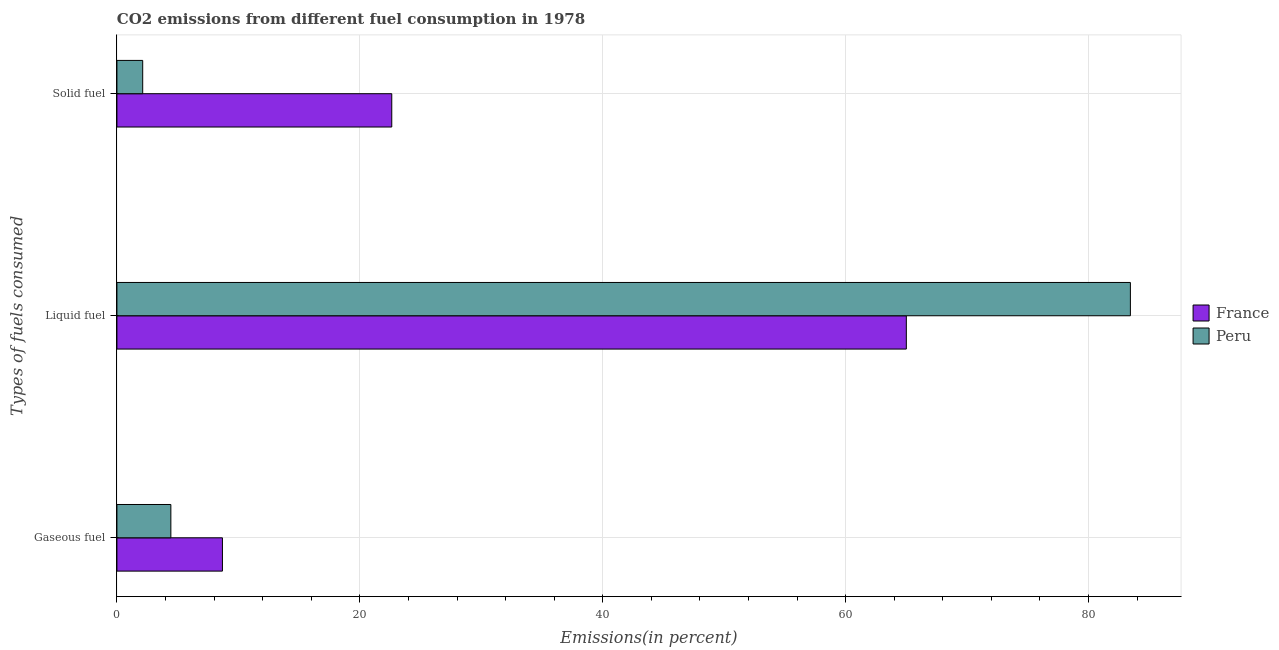How many groups of bars are there?
Provide a short and direct response. 3. Are the number of bars per tick equal to the number of legend labels?
Make the answer very short. Yes. How many bars are there on the 1st tick from the top?
Give a very brief answer. 2. What is the label of the 3rd group of bars from the top?
Make the answer very short. Gaseous fuel. What is the percentage of liquid fuel emission in France?
Offer a terse response. 65. Across all countries, what is the maximum percentage of liquid fuel emission?
Offer a terse response. 83.44. Across all countries, what is the minimum percentage of gaseous fuel emission?
Keep it short and to the point. 4.44. In which country was the percentage of gaseous fuel emission maximum?
Provide a succinct answer. France. In which country was the percentage of gaseous fuel emission minimum?
Provide a short and direct response. Peru. What is the total percentage of liquid fuel emission in the graph?
Your response must be concise. 148.44. What is the difference between the percentage of liquid fuel emission in Peru and that in France?
Your answer should be very brief. 18.45. What is the difference between the percentage of gaseous fuel emission in France and the percentage of liquid fuel emission in Peru?
Keep it short and to the point. -74.76. What is the average percentage of solid fuel emission per country?
Your answer should be compact. 12.38. What is the difference between the percentage of gaseous fuel emission and percentage of liquid fuel emission in France?
Provide a short and direct response. -56.31. What is the ratio of the percentage of gaseous fuel emission in Peru to that in France?
Make the answer very short. 0.51. Is the difference between the percentage of liquid fuel emission in France and Peru greater than the difference between the percentage of gaseous fuel emission in France and Peru?
Offer a terse response. No. What is the difference between the highest and the second highest percentage of solid fuel emission?
Your response must be concise. 20.51. What is the difference between the highest and the lowest percentage of solid fuel emission?
Offer a terse response. 20.51. In how many countries, is the percentage of gaseous fuel emission greater than the average percentage of gaseous fuel emission taken over all countries?
Keep it short and to the point. 1. Is the sum of the percentage of gaseous fuel emission in France and Peru greater than the maximum percentage of liquid fuel emission across all countries?
Offer a very short reply. No. What does the 1st bar from the top in Gaseous fuel represents?
Offer a terse response. Peru. What does the 2nd bar from the bottom in Solid fuel represents?
Give a very brief answer. Peru. Is it the case that in every country, the sum of the percentage of gaseous fuel emission and percentage of liquid fuel emission is greater than the percentage of solid fuel emission?
Offer a terse response. Yes. How many bars are there?
Provide a succinct answer. 6. Are all the bars in the graph horizontal?
Give a very brief answer. Yes. Are the values on the major ticks of X-axis written in scientific E-notation?
Your response must be concise. No. Where does the legend appear in the graph?
Your response must be concise. Center right. What is the title of the graph?
Keep it short and to the point. CO2 emissions from different fuel consumption in 1978. Does "Lao PDR" appear as one of the legend labels in the graph?
Your response must be concise. No. What is the label or title of the X-axis?
Offer a terse response. Emissions(in percent). What is the label or title of the Y-axis?
Provide a short and direct response. Types of fuels consumed. What is the Emissions(in percent) of France in Gaseous fuel?
Your response must be concise. 8.69. What is the Emissions(in percent) of Peru in Gaseous fuel?
Your answer should be compact. 4.44. What is the Emissions(in percent) in France in Liquid fuel?
Keep it short and to the point. 65. What is the Emissions(in percent) of Peru in Liquid fuel?
Offer a very short reply. 83.44. What is the Emissions(in percent) in France in Solid fuel?
Keep it short and to the point. 22.63. What is the Emissions(in percent) in Peru in Solid fuel?
Make the answer very short. 2.12. Across all Types of fuels consumed, what is the maximum Emissions(in percent) in France?
Provide a short and direct response. 65. Across all Types of fuels consumed, what is the maximum Emissions(in percent) of Peru?
Make the answer very short. 83.44. Across all Types of fuels consumed, what is the minimum Emissions(in percent) of France?
Offer a very short reply. 8.69. Across all Types of fuels consumed, what is the minimum Emissions(in percent) of Peru?
Give a very brief answer. 2.12. What is the total Emissions(in percent) of France in the graph?
Provide a short and direct response. 96.31. What is the total Emissions(in percent) in Peru in the graph?
Your response must be concise. 90.01. What is the difference between the Emissions(in percent) in France in Gaseous fuel and that in Liquid fuel?
Give a very brief answer. -56.31. What is the difference between the Emissions(in percent) of Peru in Gaseous fuel and that in Liquid fuel?
Your response must be concise. -79. What is the difference between the Emissions(in percent) in France in Gaseous fuel and that in Solid fuel?
Your answer should be compact. -13.94. What is the difference between the Emissions(in percent) of Peru in Gaseous fuel and that in Solid fuel?
Make the answer very short. 2.32. What is the difference between the Emissions(in percent) in France in Liquid fuel and that in Solid fuel?
Keep it short and to the point. 42.37. What is the difference between the Emissions(in percent) of Peru in Liquid fuel and that in Solid fuel?
Ensure brevity in your answer.  81.32. What is the difference between the Emissions(in percent) of France in Gaseous fuel and the Emissions(in percent) of Peru in Liquid fuel?
Your answer should be very brief. -74.76. What is the difference between the Emissions(in percent) of France in Gaseous fuel and the Emissions(in percent) of Peru in Solid fuel?
Ensure brevity in your answer.  6.56. What is the difference between the Emissions(in percent) in France in Liquid fuel and the Emissions(in percent) in Peru in Solid fuel?
Provide a succinct answer. 62.87. What is the average Emissions(in percent) of France per Types of fuels consumed?
Give a very brief answer. 32.1. What is the average Emissions(in percent) of Peru per Types of fuels consumed?
Your answer should be very brief. 30. What is the difference between the Emissions(in percent) of France and Emissions(in percent) of Peru in Gaseous fuel?
Give a very brief answer. 4.25. What is the difference between the Emissions(in percent) in France and Emissions(in percent) in Peru in Liquid fuel?
Make the answer very short. -18.45. What is the difference between the Emissions(in percent) of France and Emissions(in percent) of Peru in Solid fuel?
Offer a very short reply. 20.51. What is the ratio of the Emissions(in percent) of France in Gaseous fuel to that in Liquid fuel?
Give a very brief answer. 0.13. What is the ratio of the Emissions(in percent) of Peru in Gaseous fuel to that in Liquid fuel?
Give a very brief answer. 0.05. What is the ratio of the Emissions(in percent) in France in Gaseous fuel to that in Solid fuel?
Your response must be concise. 0.38. What is the ratio of the Emissions(in percent) in Peru in Gaseous fuel to that in Solid fuel?
Your answer should be compact. 2.09. What is the ratio of the Emissions(in percent) in France in Liquid fuel to that in Solid fuel?
Ensure brevity in your answer.  2.87. What is the ratio of the Emissions(in percent) of Peru in Liquid fuel to that in Solid fuel?
Make the answer very short. 39.32. What is the difference between the highest and the second highest Emissions(in percent) of France?
Offer a terse response. 42.37. What is the difference between the highest and the second highest Emissions(in percent) in Peru?
Provide a succinct answer. 79. What is the difference between the highest and the lowest Emissions(in percent) in France?
Your answer should be very brief. 56.31. What is the difference between the highest and the lowest Emissions(in percent) of Peru?
Your answer should be compact. 81.32. 